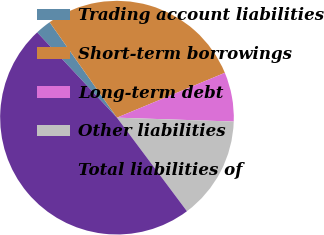Convert chart. <chart><loc_0><loc_0><loc_500><loc_500><pie_chart><fcel>Trading account liabilities<fcel>Short-term borrowings<fcel>Long-term debt<fcel>Other liabilities<fcel>Total liabilities of<nl><fcel>2.19%<fcel>28.51%<fcel>6.8%<fcel>14.25%<fcel>48.25%<nl></chart> 